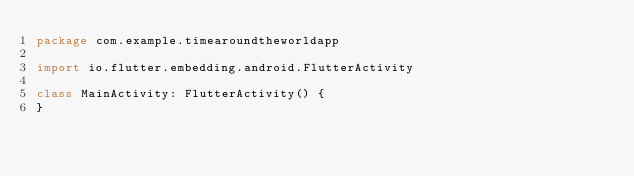Convert code to text. <code><loc_0><loc_0><loc_500><loc_500><_Kotlin_>package com.example.timearoundtheworldapp

import io.flutter.embedding.android.FlutterActivity

class MainActivity: FlutterActivity() {
}
</code> 